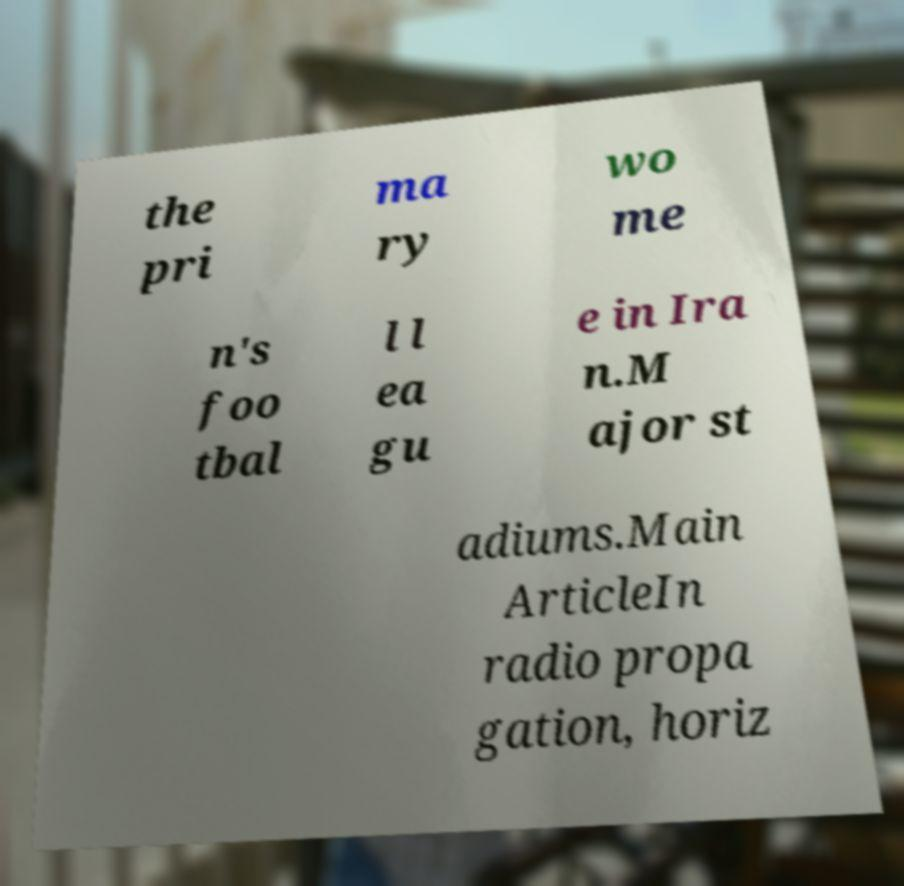Can you read and provide the text displayed in the image?This photo seems to have some interesting text. Can you extract and type it out for me? the pri ma ry wo me n's foo tbal l l ea gu e in Ira n.M ajor st adiums.Main ArticleIn radio propa gation, horiz 